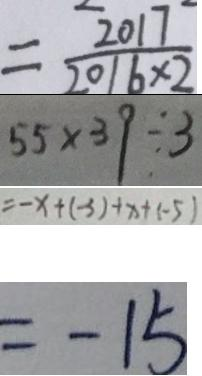Convert formula to latex. <formula><loc_0><loc_0><loc_500><loc_500>= \frac { 2 0 1 7 } { 2 0 1 6 \times 2 } 
 5 5 \times 3 9 \div 3 
 = - x + ( - 3 ) + x + ( - 5 ) 
 = - 1 5</formula> 